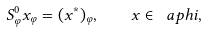<formula> <loc_0><loc_0><loc_500><loc_500>S _ { \varphi } ^ { 0 } x _ { \varphi } = ( x ^ { * } ) _ { \varphi } , \quad x \in \ a p h i ,</formula> 